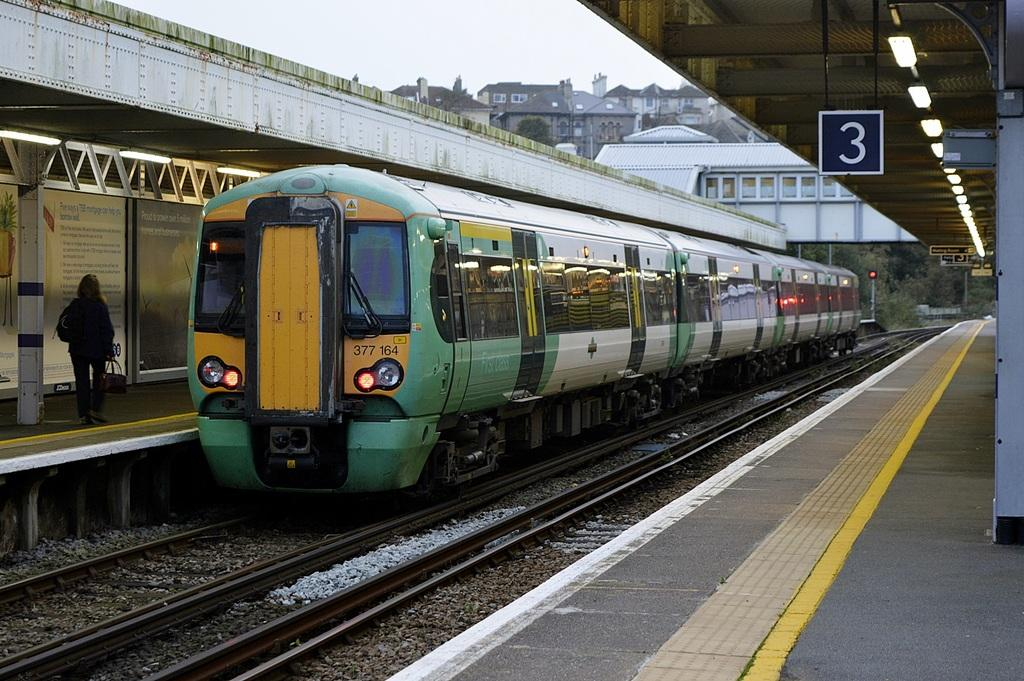<image>
Describe the image concisely. A train arrives at the number 3 station. 